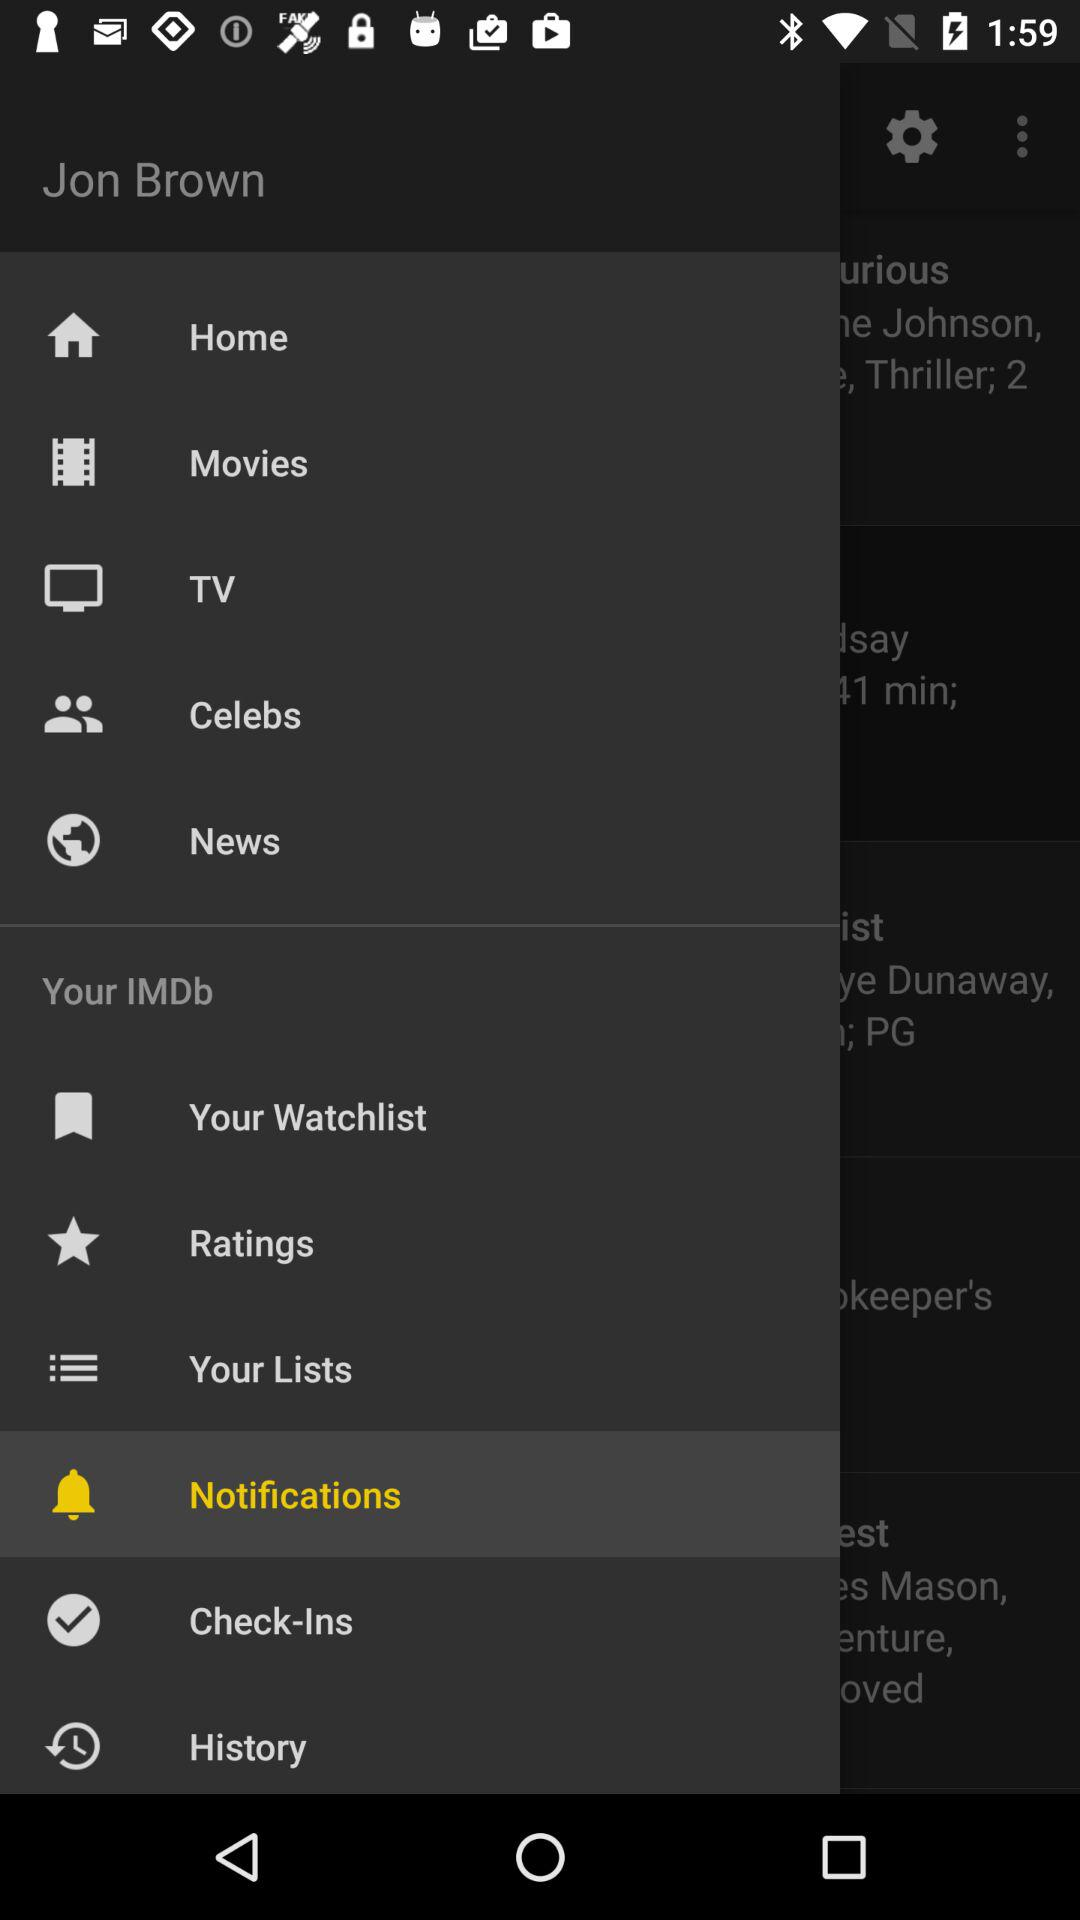What is the user name? The user name is Jon Brown. 